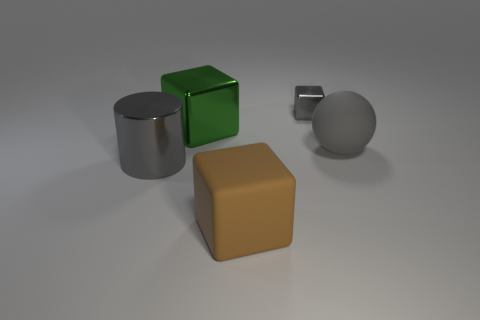Add 5 brown cubes. How many objects exist? 10 Subtract all metallic cubes. How many cubes are left? 1 Subtract all brown cylinders. How many gray blocks are left? 1 Add 4 big gray cylinders. How many big gray cylinders are left? 5 Add 1 tiny cyan shiny cylinders. How many tiny cyan shiny cylinders exist? 1 Subtract all gray cubes. How many cubes are left? 2 Subtract 0 cyan balls. How many objects are left? 5 Subtract all cylinders. How many objects are left? 4 Subtract 2 cubes. How many cubes are left? 1 Subtract all cyan blocks. Subtract all green cylinders. How many blocks are left? 3 